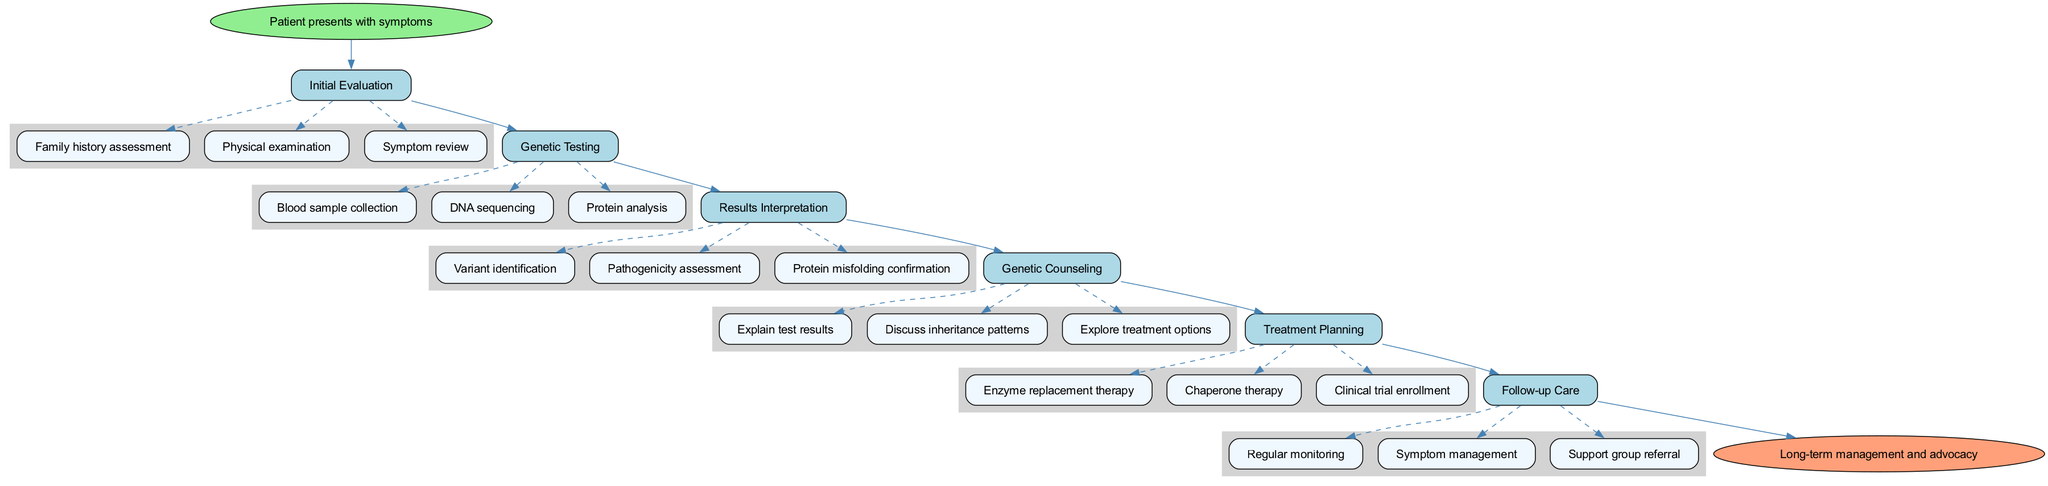What is the starting point of the clinical pathway? The clinical pathway starts with the node labeled "Patient presents with symptoms." This is indicated as the first node in the diagram that leads to the subsequent steps.
Answer: Patient presents with symptoms How many steps are included in the clinical pathway? There are six steps outlined in the pathway, each represented as a box connecting the start and end nodes sequentially. These steps can be counted directly from the diagram's flow.
Answer: 6 What is the last step before the endpoint? The last step before reaching the endpoint is "Follow-up Care." This is the final box in the sequence leading to the end node, indicating ongoing management after treatment planning.
Answer: Follow-up Care Which test is involved in the "Genetic Testing" step? The "Genetic Testing" step involves "DNA sequencing" among other testing methods. This method is explicitly listed as one of the elements under this step.
Answer: DNA sequencing What follows "Results Interpretation" in the clinical pathway? "Genetic Counseling" follows "Results Interpretation" in the sequence of steps. This can be observed as a direct connection from one step to the next in the flow.
Answer: Genetic Counseling How many elements are listed under "Genetic Counseling"? There are three elements listed under the "Genetic Counseling" step. They include "Explain test results," "Discuss inheritance patterns," and "Explore treatment options." This can be verified by counting the elements connected to that step in the diagram.
Answer: 3 What is the focus of the "Treatment Planning" step? The focus of the "Treatment Planning" step is on options such as "Enzyme replacement therapy," "Chaperone therapy," and "Clinical trial enrollment." Each of these represents a method of addressing the genetic disorder identified in previous steps.
Answer: Enzyme replacement therapy Which edge connects the "Genetic Testing" step to "Results Interpretation"? The edge connecting these two steps signifies the flow from "Genetic Testing" to "Results Interpretation," representing the process of reviewing test outcomes after testing is completed.
Answer: Results Interpretation What is the end goal of the clinical pathway? The end goal of the clinical pathway is "Long-term management and advocacy." This is encapsulated in the endpoint node and summarizes the ultimate aim of the pathway after all steps are completed.
Answer: Long-term management and advocacy 